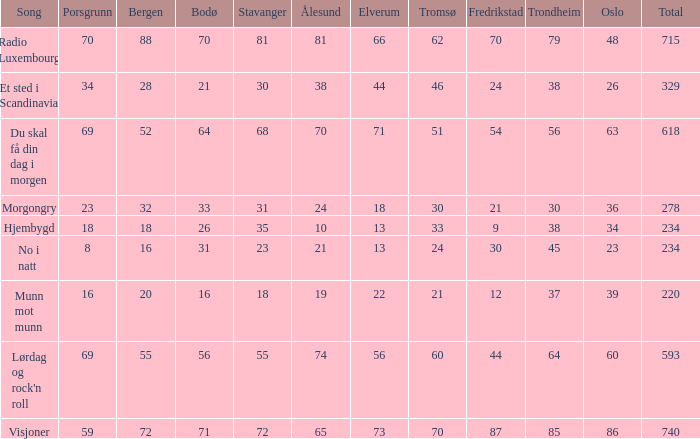What is the lowest total? 220.0. 